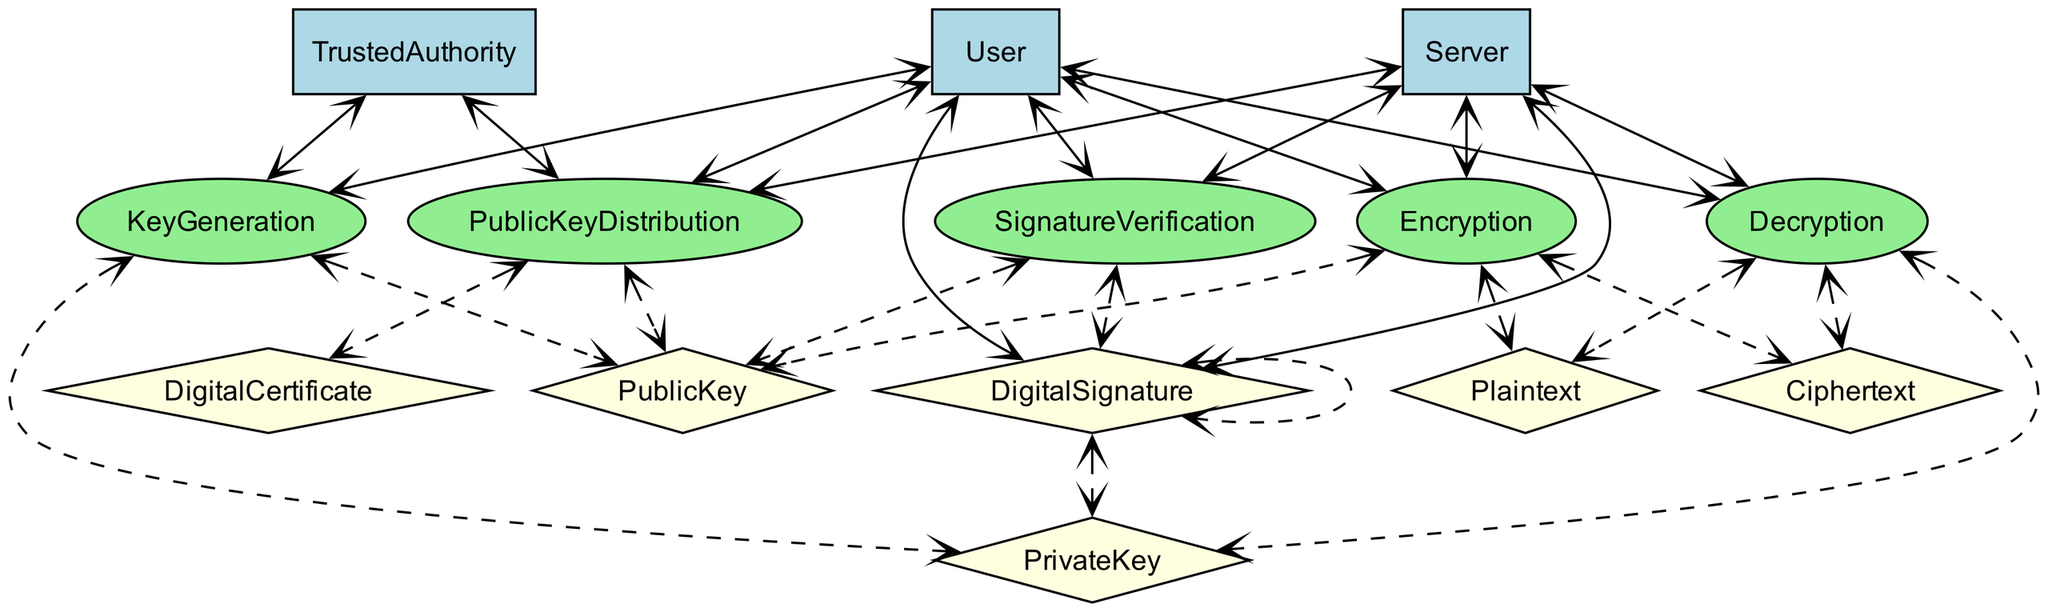What are the entities involved in key generation? The diagram lists "User" and "TrustedAuthority" as the entities involved in the KeyGeneration process.
Answer: User, TrustedAuthority How many processes are represented in the diagram? By counting the nodes labeled as processes, there are a total of six processes: KeyGeneration, PublicKeyDistribution, Encryption, Decryption, DigitalSignature, and SignatureVerification.
Answer: 6 Which entity is responsible for public key distribution? The "TrustedAuthority" is responsible for the PublicKeyDistribution process as indicated in the diagram.
Answer: TrustedAuthority What is the output of the encryption process? The encryption process outputs "Ciphertext," which is explicitly mentioned as the result of the Encryption process in the diagram.
Answer: Ciphertext What data is created during the digital signature process? The "DigitalSignature" is created during the DigitalSignature process as depicted in the diagram.
Answer: DigitalSignature Which two entities are involved in both the encryption and decryption processes? Both "User" and "Server" are involved in the Encryption and Decryption processes, as shown by the edges connecting them to these processes.
Answer: User, Server What is the role of the trusted authority in public key distribution? The trusted authority issues and verifies public keys during the PublicKeyDistribution process, ensuring that the keys are authentic and trustworthy when disseminated to users and servers.
Answer: Issues, verifies public keys How does the process of signature verification relate to digital certificates? The SignatureVerification process involves the use of the "PublicKey," which is contained in a "DigitalCertificate," establishing trust in the signature's authenticity as shown by the nodes' connections in the diagram.
Answer: Relates via PublicKey in DigitalCertificate What is the relationship between the decryption process and the private key? The decryption process uses the "PrivateKey" to convert ciphertext back into plaintext, as indicated in the diagram, demonstrating the function of the private key in this cryptographic operation.
Answer: Uses PrivateKey 